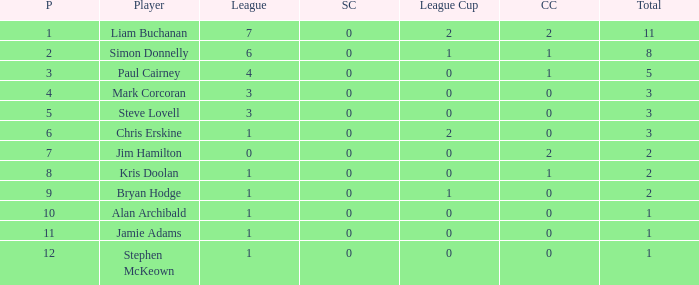What is Kris doolan's league number? 1.0. 